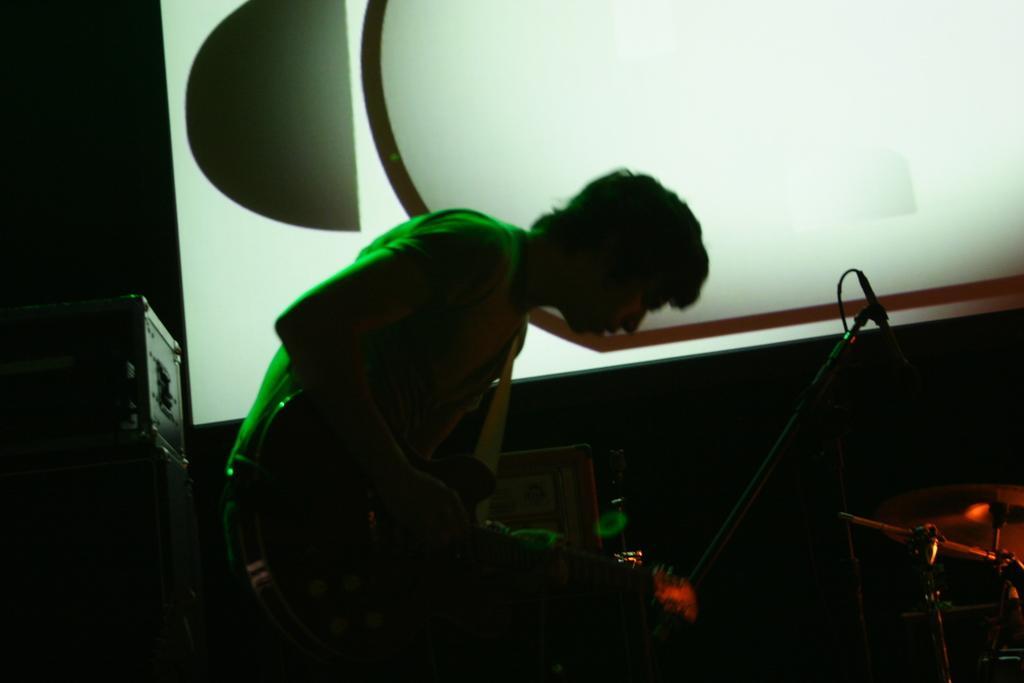Please provide a concise description of this image. In this image there is a person holding a guitar and in front of him there is a mike and some other musical instruments and beside him there is an LCD screen. 